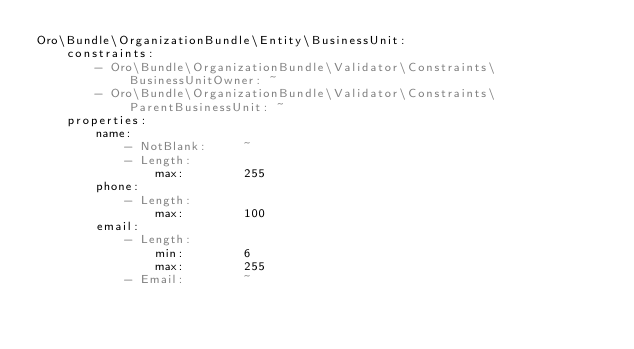<code> <loc_0><loc_0><loc_500><loc_500><_YAML_>Oro\Bundle\OrganizationBundle\Entity\BusinessUnit:
    constraints:
        - Oro\Bundle\OrganizationBundle\Validator\Constraints\BusinessUnitOwner: ~
        - Oro\Bundle\OrganizationBundle\Validator\Constraints\ParentBusinessUnit: ~
    properties:
        name:
            - NotBlank:     ~
            - Length:
                max:        255
        phone:
            - Length:
                max:        100
        email:
            - Length:
                min:        6
                max:        255
            - Email:        ~
</code> 